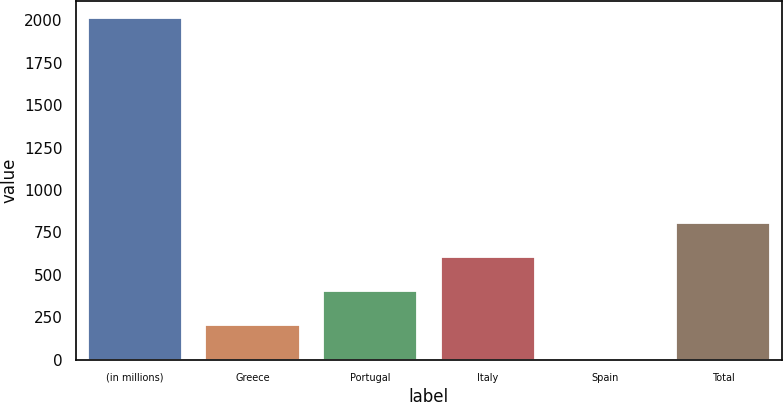Convert chart. <chart><loc_0><loc_0><loc_500><loc_500><bar_chart><fcel>(in millions)<fcel>Greece<fcel>Portugal<fcel>Italy<fcel>Spain<fcel>Total<nl><fcel>2012<fcel>203<fcel>404<fcel>605<fcel>2<fcel>806<nl></chart> 